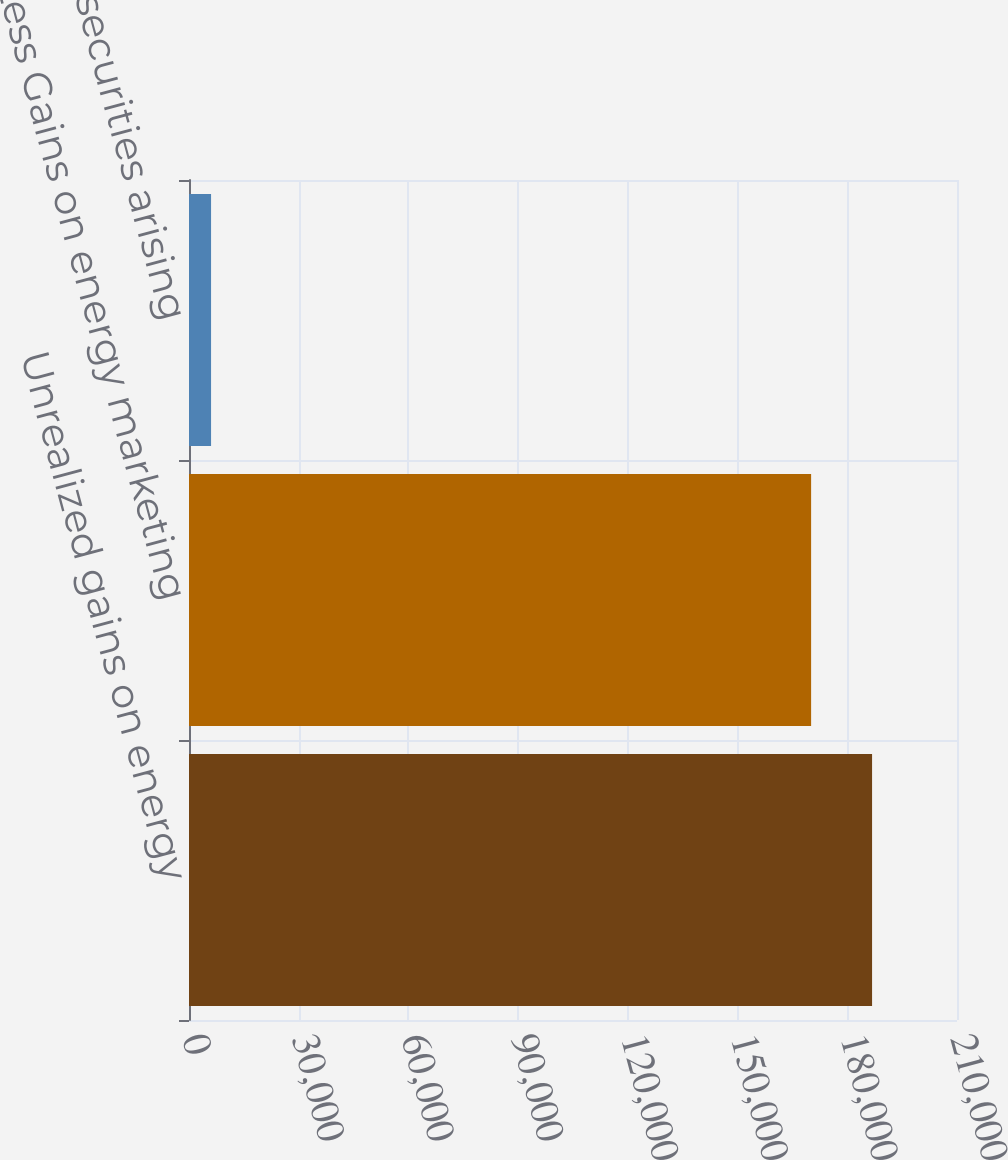Convert chart. <chart><loc_0><loc_0><loc_500><loc_500><bar_chart><fcel>Unrealized gains on energy<fcel>Less Gains on energy marketing<fcel>investment securities arising<nl><fcel>186776<fcel>170110<fcel>6032<nl></chart> 